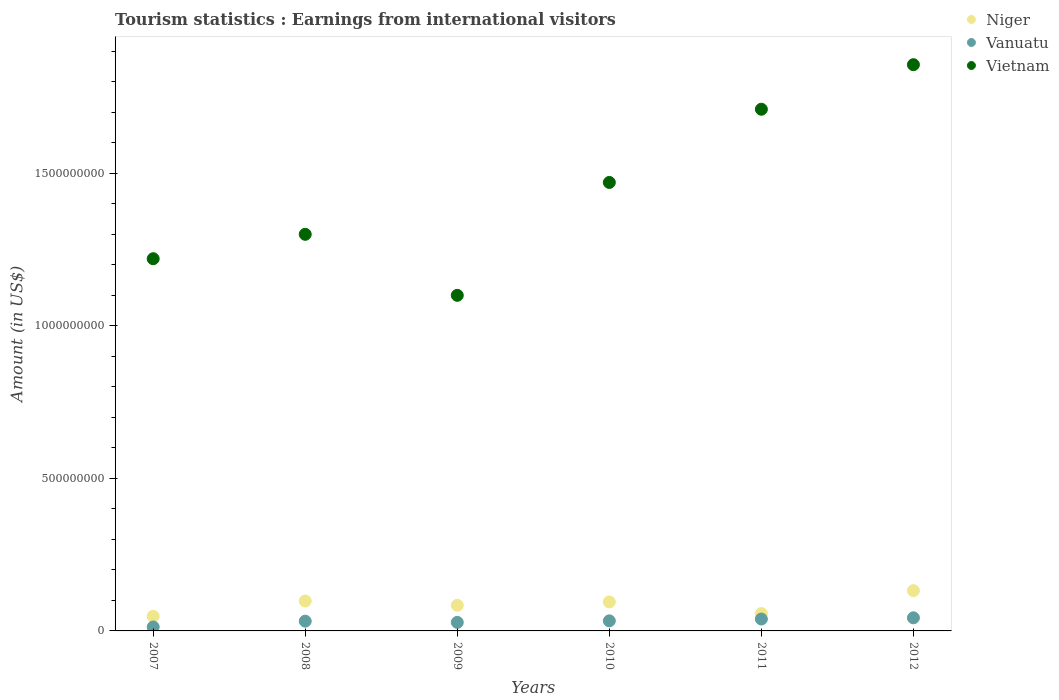What is the earnings from international visitors in Vanuatu in 2010?
Offer a very short reply. 3.30e+07. Across all years, what is the maximum earnings from international visitors in Vietnam?
Offer a terse response. 1.86e+09. Across all years, what is the minimum earnings from international visitors in Niger?
Give a very brief answer. 4.80e+07. In which year was the earnings from international visitors in Vietnam maximum?
Your answer should be compact. 2012. In which year was the earnings from international visitors in Vietnam minimum?
Provide a succinct answer. 2009. What is the total earnings from international visitors in Vietnam in the graph?
Keep it short and to the point. 8.66e+09. What is the difference between the earnings from international visitors in Niger in 2007 and that in 2011?
Provide a succinct answer. -9.00e+06. What is the difference between the earnings from international visitors in Niger in 2010 and the earnings from international visitors in Vietnam in 2009?
Your response must be concise. -1.00e+09. What is the average earnings from international visitors in Niger per year?
Make the answer very short. 8.57e+07. In the year 2009, what is the difference between the earnings from international visitors in Vanuatu and earnings from international visitors in Niger?
Ensure brevity in your answer.  -5.60e+07. What is the ratio of the earnings from international visitors in Vietnam in 2007 to that in 2012?
Offer a terse response. 0.66. Is the earnings from international visitors in Niger in 2007 less than that in 2011?
Make the answer very short. Yes. Is the difference between the earnings from international visitors in Vanuatu in 2009 and 2010 greater than the difference between the earnings from international visitors in Niger in 2009 and 2010?
Your answer should be compact. Yes. What is the difference between the highest and the second highest earnings from international visitors in Vietnam?
Provide a succinct answer. 1.46e+08. What is the difference between the highest and the lowest earnings from international visitors in Niger?
Provide a succinct answer. 8.40e+07. Is the sum of the earnings from international visitors in Vanuatu in 2010 and 2011 greater than the maximum earnings from international visitors in Vietnam across all years?
Offer a very short reply. No. Is it the case that in every year, the sum of the earnings from international visitors in Vietnam and earnings from international visitors in Niger  is greater than the earnings from international visitors in Vanuatu?
Ensure brevity in your answer.  Yes. Does the earnings from international visitors in Vanuatu monotonically increase over the years?
Give a very brief answer. No. Is the earnings from international visitors in Niger strictly greater than the earnings from international visitors in Vanuatu over the years?
Provide a succinct answer. Yes. How many dotlines are there?
Make the answer very short. 3. What is the difference between two consecutive major ticks on the Y-axis?
Offer a very short reply. 5.00e+08. Where does the legend appear in the graph?
Make the answer very short. Top right. How many legend labels are there?
Your answer should be very brief. 3. How are the legend labels stacked?
Your answer should be very brief. Vertical. What is the title of the graph?
Give a very brief answer. Tourism statistics : Earnings from international visitors. Does "Spain" appear as one of the legend labels in the graph?
Your response must be concise. No. What is the Amount (in US$) of Niger in 2007?
Offer a terse response. 4.80e+07. What is the Amount (in US$) in Vanuatu in 2007?
Keep it short and to the point. 1.30e+07. What is the Amount (in US$) of Vietnam in 2007?
Your response must be concise. 1.22e+09. What is the Amount (in US$) in Niger in 2008?
Ensure brevity in your answer.  9.80e+07. What is the Amount (in US$) in Vanuatu in 2008?
Your answer should be very brief. 3.20e+07. What is the Amount (in US$) of Vietnam in 2008?
Ensure brevity in your answer.  1.30e+09. What is the Amount (in US$) in Niger in 2009?
Offer a very short reply. 8.40e+07. What is the Amount (in US$) of Vanuatu in 2009?
Your answer should be very brief. 2.80e+07. What is the Amount (in US$) of Vietnam in 2009?
Your answer should be very brief. 1.10e+09. What is the Amount (in US$) in Niger in 2010?
Offer a terse response. 9.50e+07. What is the Amount (in US$) in Vanuatu in 2010?
Offer a very short reply. 3.30e+07. What is the Amount (in US$) in Vietnam in 2010?
Make the answer very short. 1.47e+09. What is the Amount (in US$) of Niger in 2011?
Offer a terse response. 5.70e+07. What is the Amount (in US$) of Vanuatu in 2011?
Your answer should be very brief. 3.90e+07. What is the Amount (in US$) of Vietnam in 2011?
Give a very brief answer. 1.71e+09. What is the Amount (in US$) in Niger in 2012?
Make the answer very short. 1.32e+08. What is the Amount (in US$) of Vanuatu in 2012?
Ensure brevity in your answer.  4.30e+07. What is the Amount (in US$) of Vietnam in 2012?
Your answer should be compact. 1.86e+09. Across all years, what is the maximum Amount (in US$) in Niger?
Offer a very short reply. 1.32e+08. Across all years, what is the maximum Amount (in US$) in Vanuatu?
Keep it short and to the point. 4.30e+07. Across all years, what is the maximum Amount (in US$) in Vietnam?
Your answer should be very brief. 1.86e+09. Across all years, what is the minimum Amount (in US$) of Niger?
Keep it short and to the point. 4.80e+07. Across all years, what is the minimum Amount (in US$) of Vanuatu?
Your answer should be very brief. 1.30e+07. Across all years, what is the minimum Amount (in US$) of Vietnam?
Provide a short and direct response. 1.10e+09. What is the total Amount (in US$) in Niger in the graph?
Your answer should be compact. 5.14e+08. What is the total Amount (in US$) of Vanuatu in the graph?
Offer a terse response. 1.88e+08. What is the total Amount (in US$) in Vietnam in the graph?
Offer a terse response. 8.66e+09. What is the difference between the Amount (in US$) in Niger in 2007 and that in 2008?
Offer a very short reply. -5.00e+07. What is the difference between the Amount (in US$) in Vanuatu in 2007 and that in 2008?
Offer a terse response. -1.90e+07. What is the difference between the Amount (in US$) in Vietnam in 2007 and that in 2008?
Offer a very short reply. -8.00e+07. What is the difference between the Amount (in US$) in Niger in 2007 and that in 2009?
Provide a succinct answer. -3.60e+07. What is the difference between the Amount (in US$) in Vanuatu in 2007 and that in 2009?
Your answer should be very brief. -1.50e+07. What is the difference between the Amount (in US$) in Vietnam in 2007 and that in 2009?
Keep it short and to the point. 1.20e+08. What is the difference between the Amount (in US$) in Niger in 2007 and that in 2010?
Keep it short and to the point. -4.70e+07. What is the difference between the Amount (in US$) of Vanuatu in 2007 and that in 2010?
Offer a terse response. -2.00e+07. What is the difference between the Amount (in US$) of Vietnam in 2007 and that in 2010?
Provide a short and direct response. -2.50e+08. What is the difference between the Amount (in US$) of Niger in 2007 and that in 2011?
Provide a short and direct response. -9.00e+06. What is the difference between the Amount (in US$) of Vanuatu in 2007 and that in 2011?
Offer a terse response. -2.60e+07. What is the difference between the Amount (in US$) in Vietnam in 2007 and that in 2011?
Your response must be concise. -4.90e+08. What is the difference between the Amount (in US$) of Niger in 2007 and that in 2012?
Your answer should be compact. -8.40e+07. What is the difference between the Amount (in US$) in Vanuatu in 2007 and that in 2012?
Your response must be concise. -3.00e+07. What is the difference between the Amount (in US$) in Vietnam in 2007 and that in 2012?
Offer a terse response. -6.36e+08. What is the difference between the Amount (in US$) in Niger in 2008 and that in 2009?
Give a very brief answer. 1.40e+07. What is the difference between the Amount (in US$) in Vanuatu in 2008 and that in 2009?
Give a very brief answer. 4.00e+06. What is the difference between the Amount (in US$) in Vanuatu in 2008 and that in 2010?
Your answer should be very brief. -1.00e+06. What is the difference between the Amount (in US$) of Vietnam in 2008 and that in 2010?
Your answer should be compact. -1.70e+08. What is the difference between the Amount (in US$) in Niger in 2008 and that in 2011?
Your answer should be compact. 4.10e+07. What is the difference between the Amount (in US$) in Vanuatu in 2008 and that in 2011?
Keep it short and to the point. -7.00e+06. What is the difference between the Amount (in US$) of Vietnam in 2008 and that in 2011?
Ensure brevity in your answer.  -4.10e+08. What is the difference between the Amount (in US$) of Niger in 2008 and that in 2012?
Your answer should be compact. -3.40e+07. What is the difference between the Amount (in US$) of Vanuatu in 2008 and that in 2012?
Your response must be concise. -1.10e+07. What is the difference between the Amount (in US$) in Vietnam in 2008 and that in 2012?
Your answer should be very brief. -5.56e+08. What is the difference between the Amount (in US$) in Niger in 2009 and that in 2010?
Offer a very short reply. -1.10e+07. What is the difference between the Amount (in US$) of Vanuatu in 2009 and that in 2010?
Your response must be concise. -5.00e+06. What is the difference between the Amount (in US$) in Vietnam in 2009 and that in 2010?
Offer a terse response. -3.70e+08. What is the difference between the Amount (in US$) in Niger in 2009 and that in 2011?
Provide a short and direct response. 2.70e+07. What is the difference between the Amount (in US$) of Vanuatu in 2009 and that in 2011?
Ensure brevity in your answer.  -1.10e+07. What is the difference between the Amount (in US$) of Vietnam in 2009 and that in 2011?
Make the answer very short. -6.10e+08. What is the difference between the Amount (in US$) of Niger in 2009 and that in 2012?
Ensure brevity in your answer.  -4.80e+07. What is the difference between the Amount (in US$) of Vanuatu in 2009 and that in 2012?
Give a very brief answer. -1.50e+07. What is the difference between the Amount (in US$) of Vietnam in 2009 and that in 2012?
Keep it short and to the point. -7.56e+08. What is the difference between the Amount (in US$) of Niger in 2010 and that in 2011?
Your answer should be compact. 3.80e+07. What is the difference between the Amount (in US$) in Vanuatu in 2010 and that in 2011?
Ensure brevity in your answer.  -6.00e+06. What is the difference between the Amount (in US$) of Vietnam in 2010 and that in 2011?
Your response must be concise. -2.40e+08. What is the difference between the Amount (in US$) in Niger in 2010 and that in 2012?
Provide a succinct answer. -3.70e+07. What is the difference between the Amount (in US$) of Vanuatu in 2010 and that in 2012?
Ensure brevity in your answer.  -1.00e+07. What is the difference between the Amount (in US$) of Vietnam in 2010 and that in 2012?
Your answer should be very brief. -3.86e+08. What is the difference between the Amount (in US$) of Niger in 2011 and that in 2012?
Offer a very short reply. -7.50e+07. What is the difference between the Amount (in US$) of Vietnam in 2011 and that in 2012?
Provide a succinct answer. -1.46e+08. What is the difference between the Amount (in US$) of Niger in 2007 and the Amount (in US$) of Vanuatu in 2008?
Offer a very short reply. 1.60e+07. What is the difference between the Amount (in US$) in Niger in 2007 and the Amount (in US$) in Vietnam in 2008?
Your answer should be very brief. -1.25e+09. What is the difference between the Amount (in US$) in Vanuatu in 2007 and the Amount (in US$) in Vietnam in 2008?
Your answer should be very brief. -1.29e+09. What is the difference between the Amount (in US$) in Niger in 2007 and the Amount (in US$) in Vietnam in 2009?
Offer a terse response. -1.05e+09. What is the difference between the Amount (in US$) in Vanuatu in 2007 and the Amount (in US$) in Vietnam in 2009?
Provide a succinct answer. -1.09e+09. What is the difference between the Amount (in US$) of Niger in 2007 and the Amount (in US$) of Vanuatu in 2010?
Your answer should be compact. 1.50e+07. What is the difference between the Amount (in US$) in Niger in 2007 and the Amount (in US$) in Vietnam in 2010?
Your answer should be compact. -1.42e+09. What is the difference between the Amount (in US$) in Vanuatu in 2007 and the Amount (in US$) in Vietnam in 2010?
Offer a terse response. -1.46e+09. What is the difference between the Amount (in US$) in Niger in 2007 and the Amount (in US$) in Vanuatu in 2011?
Your answer should be very brief. 9.00e+06. What is the difference between the Amount (in US$) in Niger in 2007 and the Amount (in US$) in Vietnam in 2011?
Make the answer very short. -1.66e+09. What is the difference between the Amount (in US$) in Vanuatu in 2007 and the Amount (in US$) in Vietnam in 2011?
Make the answer very short. -1.70e+09. What is the difference between the Amount (in US$) of Niger in 2007 and the Amount (in US$) of Vietnam in 2012?
Your response must be concise. -1.81e+09. What is the difference between the Amount (in US$) of Vanuatu in 2007 and the Amount (in US$) of Vietnam in 2012?
Provide a short and direct response. -1.84e+09. What is the difference between the Amount (in US$) of Niger in 2008 and the Amount (in US$) of Vanuatu in 2009?
Offer a very short reply. 7.00e+07. What is the difference between the Amount (in US$) in Niger in 2008 and the Amount (in US$) in Vietnam in 2009?
Make the answer very short. -1.00e+09. What is the difference between the Amount (in US$) of Vanuatu in 2008 and the Amount (in US$) of Vietnam in 2009?
Offer a very short reply. -1.07e+09. What is the difference between the Amount (in US$) in Niger in 2008 and the Amount (in US$) in Vanuatu in 2010?
Make the answer very short. 6.50e+07. What is the difference between the Amount (in US$) of Niger in 2008 and the Amount (in US$) of Vietnam in 2010?
Offer a terse response. -1.37e+09. What is the difference between the Amount (in US$) of Vanuatu in 2008 and the Amount (in US$) of Vietnam in 2010?
Make the answer very short. -1.44e+09. What is the difference between the Amount (in US$) in Niger in 2008 and the Amount (in US$) in Vanuatu in 2011?
Your answer should be very brief. 5.90e+07. What is the difference between the Amount (in US$) in Niger in 2008 and the Amount (in US$) in Vietnam in 2011?
Your answer should be compact. -1.61e+09. What is the difference between the Amount (in US$) in Vanuatu in 2008 and the Amount (in US$) in Vietnam in 2011?
Offer a very short reply. -1.68e+09. What is the difference between the Amount (in US$) in Niger in 2008 and the Amount (in US$) in Vanuatu in 2012?
Keep it short and to the point. 5.50e+07. What is the difference between the Amount (in US$) in Niger in 2008 and the Amount (in US$) in Vietnam in 2012?
Provide a succinct answer. -1.76e+09. What is the difference between the Amount (in US$) in Vanuatu in 2008 and the Amount (in US$) in Vietnam in 2012?
Your answer should be compact. -1.82e+09. What is the difference between the Amount (in US$) in Niger in 2009 and the Amount (in US$) in Vanuatu in 2010?
Ensure brevity in your answer.  5.10e+07. What is the difference between the Amount (in US$) of Niger in 2009 and the Amount (in US$) of Vietnam in 2010?
Ensure brevity in your answer.  -1.39e+09. What is the difference between the Amount (in US$) in Vanuatu in 2009 and the Amount (in US$) in Vietnam in 2010?
Provide a succinct answer. -1.44e+09. What is the difference between the Amount (in US$) in Niger in 2009 and the Amount (in US$) in Vanuatu in 2011?
Your answer should be compact. 4.50e+07. What is the difference between the Amount (in US$) in Niger in 2009 and the Amount (in US$) in Vietnam in 2011?
Your answer should be very brief. -1.63e+09. What is the difference between the Amount (in US$) of Vanuatu in 2009 and the Amount (in US$) of Vietnam in 2011?
Your answer should be very brief. -1.68e+09. What is the difference between the Amount (in US$) in Niger in 2009 and the Amount (in US$) in Vanuatu in 2012?
Your answer should be very brief. 4.10e+07. What is the difference between the Amount (in US$) in Niger in 2009 and the Amount (in US$) in Vietnam in 2012?
Ensure brevity in your answer.  -1.77e+09. What is the difference between the Amount (in US$) in Vanuatu in 2009 and the Amount (in US$) in Vietnam in 2012?
Offer a very short reply. -1.83e+09. What is the difference between the Amount (in US$) in Niger in 2010 and the Amount (in US$) in Vanuatu in 2011?
Your answer should be very brief. 5.60e+07. What is the difference between the Amount (in US$) of Niger in 2010 and the Amount (in US$) of Vietnam in 2011?
Give a very brief answer. -1.62e+09. What is the difference between the Amount (in US$) of Vanuatu in 2010 and the Amount (in US$) of Vietnam in 2011?
Keep it short and to the point. -1.68e+09. What is the difference between the Amount (in US$) of Niger in 2010 and the Amount (in US$) of Vanuatu in 2012?
Offer a terse response. 5.20e+07. What is the difference between the Amount (in US$) of Niger in 2010 and the Amount (in US$) of Vietnam in 2012?
Ensure brevity in your answer.  -1.76e+09. What is the difference between the Amount (in US$) of Vanuatu in 2010 and the Amount (in US$) of Vietnam in 2012?
Offer a terse response. -1.82e+09. What is the difference between the Amount (in US$) in Niger in 2011 and the Amount (in US$) in Vanuatu in 2012?
Your response must be concise. 1.40e+07. What is the difference between the Amount (in US$) of Niger in 2011 and the Amount (in US$) of Vietnam in 2012?
Offer a terse response. -1.80e+09. What is the difference between the Amount (in US$) in Vanuatu in 2011 and the Amount (in US$) in Vietnam in 2012?
Offer a terse response. -1.82e+09. What is the average Amount (in US$) of Niger per year?
Your answer should be compact. 8.57e+07. What is the average Amount (in US$) of Vanuatu per year?
Make the answer very short. 3.13e+07. What is the average Amount (in US$) of Vietnam per year?
Your response must be concise. 1.44e+09. In the year 2007, what is the difference between the Amount (in US$) of Niger and Amount (in US$) of Vanuatu?
Make the answer very short. 3.50e+07. In the year 2007, what is the difference between the Amount (in US$) in Niger and Amount (in US$) in Vietnam?
Ensure brevity in your answer.  -1.17e+09. In the year 2007, what is the difference between the Amount (in US$) of Vanuatu and Amount (in US$) of Vietnam?
Offer a very short reply. -1.21e+09. In the year 2008, what is the difference between the Amount (in US$) of Niger and Amount (in US$) of Vanuatu?
Give a very brief answer. 6.60e+07. In the year 2008, what is the difference between the Amount (in US$) of Niger and Amount (in US$) of Vietnam?
Offer a terse response. -1.20e+09. In the year 2008, what is the difference between the Amount (in US$) in Vanuatu and Amount (in US$) in Vietnam?
Offer a very short reply. -1.27e+09. In the year 2009, what is the difference between the Amount (in US$) of Niger and Amount (in US$) of Vanuatu?
Make the answer very short. 5.60e+07. In the year 2009, what is the difference between the Amount (in US$) of Niger and Amount (in US$) of Vietnam?
Offer a very short reply. -1.02e+09. In the year 2009, what is the difference between the Amount (in US$) of Vanuatu and Amount (in US$) of Vietnam?
Keep it short and to the point. -1.07e+09. In the year 2010, what is the difference between the Amount (in US$) of Niger and Amount (in US$) of Vanuatu?
Offer a terse response. 6.20e+07. In the year 2010, what is the difference between the Amount (in US$) in Niger and Amount (in US$) in Vietnam?
Your answer should be compact. -1.38e+09. In the year 2010, what is the difference between the Amount (in US$) in Vanuatu and Amount (in US$) in Vietnam?
Your answer should be very brief. -1.44e+09. In the year 2011, what is the difference between the Amount (in US$) in Niger and Amount (in US$) in Vanuatu?
Offer a terse response. 1.80e+07. In the year 2011, what is the difference between the Amount (in US$) in Niger and Amount (in US$) in Vietnam?
Your answer should be compact. -1.65e+09. In the year 2011, what is the difference between the Amount (in US$) of Vanuatu and Amount (in US$) of Vietnam?
Your response must be concise. -1.67e+09. In the year 2012, what is the difference between the Amount (in US$) in Niger and Amount (in US$) in Vanuatu?
Your answer should be compact. 8.90e+07. In the year 2012, what is the difference between the Amount (in US$) in Niger and Amount (in US$) in Vietnam?
Your answer should be compact. -1.72e+09. In the year 2012, what is the difference between the Amount (in US$) in Vanuatu and Amount (in US$) in Vietnam?
Make the answer very short. -1.81e+09. What is the ratio of the Amount (in US$) of Niger in 2007 to that in 2008?
Ensure brevity in your answer.  0.49. What is the ratio of the Amount (in US$) in Vanuatu in 2007 to that in 2008?
Your answer should be very brief. 0.41. What is the ratio of the Amount (in US$) in Vietnam in 2007 to that in 2008?
Offer a very short reply. 0.94. What is the ratio of the Amount (in US$) of Niger in 2007 to that in 2009?
Provide a succinct answer. 0.57. What is the ratio of the Amount (in US$) of Vanuatu in 2007 to that in 2009?
Your answer should be compact. 0.46. What is the ratio of the Amount (in US$) of Vietnam in 2007 to that in 2009?
Provide a succinct answer. 1.11. What is the ratio of the Amount (in US$) in Niger in 2007 to that in 2010?
Provide a short and direct response. 0.51. What is the ratio of the Amount (in US$) in Vanuatu in 2007 to that in 2010?
Ensure brevity in your answer.  0.39. What is the ratio of the Amount (in US$) in Vietnam in 2007 to that in 2010?
Offer a terse response. 0.83. What is the ratio of the Amount (in US$) in Niger in 2007 to that in 2011?
Your answer should be very brief. 0.84. What is the ratio of the Amount (in US$) in Vanuatu in 2007 to that in 2011?
Offer a terse response. 0.33. What is the ratio of the Amount (in US$) of Vietnam in 2007 to that in 2011?
Provide a succinct answer. 0.71. What is the ratio of the Amount (in US$) of Niger in 2007 to that in 2012?
Offer a very short reply. 0.36. What is the ratio of the Amount (in US$) in Vanuatu in 2007 to that in 2012?
Provide a short and direct response. 0.3. What is the ratio of the Amount (in US$) of Vietnam in 2007 to that in 2012?
Offer a terse response. 0.66. What is the ratio of the Amount (in US$) of Vanuatu in 2008 to that in 2009?
Your response must be concise. 1.14. What is the ratio of the Amount (in US$) of Vietnam in 2008 to that in 2009?
Your answer should be compact. 1.18. What is the ratio of the Amount (in US$) of Niger in 2008 to that in 2010?
Ensure brevity in your answer.  1.03. What is the ratio of the Amount (in US$) in Vanuatu in 2008 to that in 2010?
Give a very brief answer. 0.97. What is the ratio of the Amount (in US$) in Vietnam in 2008 to that in 2010?
Provide a short and direct response. 0.88. What is the ratio of the Amount (in US$) in Niger in 2008 to that in 2011?
Offer a terse response. 1.72. What is the ratio of the Amount (in US$) in Vanuatu in 2008 to that in 2011?
Provide a succinct answer. 0.82. What is the ratio of the Amount (in US$) of Vietnam in 2008 to that in 2011?
Give a very brief answer. 0.76. What is the ratio of the Amount (in US$) of Niger in 2008 to that in 2012?
Provide a succinct answer. 0.74. What is the ratio of the Amount (in US$) in Vanuatu in 2008 to that in 2012?
Provide a short and direct response. 0.74. What is the ratio of the Amount (in US$) of Vietnam in 2008 to that in 2012?
Offer a very short reply. 0.7. What is the ratio of the Amount (in US$) of Niger in 2009 to that in 2010?
Offer a terse response. 0.88. What is the ratio of the Amount (in US$) of Vanuatu in 2009 to that in 2010?
Your response must be concise. 0.85. What is the ratio of the Amount (in US$) of Vietnam in 2009 to that in 2010?
Your answer should be compact. 0.75. What is the ratio of the Amount (in US$) in Niger in 2009 to that in 2011?
Your response must be concise. 1.47. What is the ratio of the Amount (in US$) in Vanuatu in 2009 to that in 2011?
Keep it short and to the point. 0.72. What is the ratio of the Amount (in US$) of Vietnam in 2009 to that in 2011?
Keep it short and to the point. 0.64. What is the ratio of the Amount (in US$) in Niger in 2009 to that in 2012?
Give a very brief answer. 0.64. What is the ratio of the Amount (in US$) of Vanuatu in 2009 to that in 2012?
Make the answer very short. 0.65. What is the ratio of the Amount (in US$) of Vietnam in 2009 to that in 2012?
Provide a succinct answer. 0.59. What is the ratio of the Amount (in US$) of Vanuatu in 2010 to that in 2011?
Ensure brevity in your answer.  0.85. What is the ratio of the Amount (in US$) of Vietnam in 2010 to that in 2011?
Offer a very short reply. 0.86. What is the ratio of the Amount (in US$) of Niger in 2010 to that in 2012?
Offer a terse response. 0.72. What is the ratio of the Amount (in US$) in Vanuatu in 2010 to that in 2012?
Provide a succinct answer. 0.77. What is the ratio of the Amount (in US$) in Vietnam in 2010 to that in 2012?
Make the answer very short. 0.79. What is the ratio of the Amount (in US$) of Niger in 2011 to that in 2012?
Your response must be concise. 0.43. What is the ratio of the Amount (in US$) of Vanuatu in 2011 to that in 2012?
Provide a succinct answer. 0.91. What is the ratio of the Amount (in US$) of Vietnam in 2011 to that in 2012?
Make the answer very short. 0.92. What is the difference between the highest and the second highest Amount (in US$) of Niger?
Keep it short and to the point. 3.40e+07. What is the difference between the highest and the second highest Amount (in US$) in Vanuatu?
Provide a short and direct response. 4.00e+06. What is the difference between the highest and the second highest Amount (in US$) in Vietnam?
Ensure brevity in your answer.  1.46e+08. What is the difference between the highest and the lowest Amount (in US$) of Niger?
Your response must be concise. 8.40e+07. What is the difference between the highest and the lowest Amount (in US$) in Vanuatu?
Your answer should be compact. 3.00e+07. What is the difference between the highest and the lowest Amount (in US$) of Vietnam?
Your answer should be compact. 7.56e+08. 